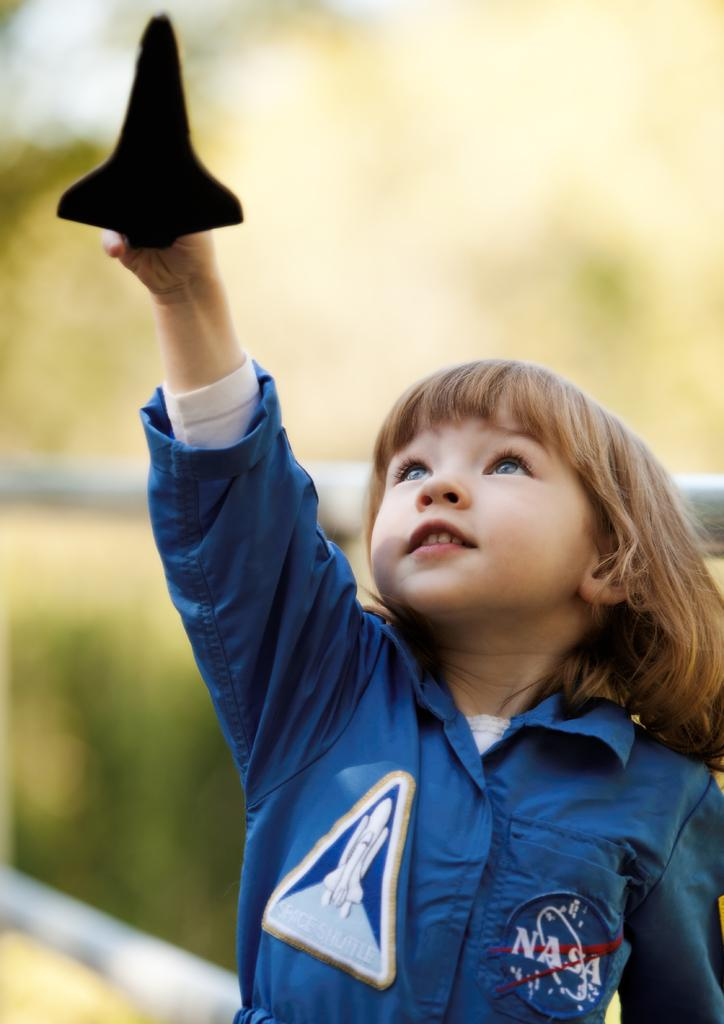<image>
Relay a brief, clear account of the picture shown. a young child with a nasa patch on their jacket playing with a toy rocket 